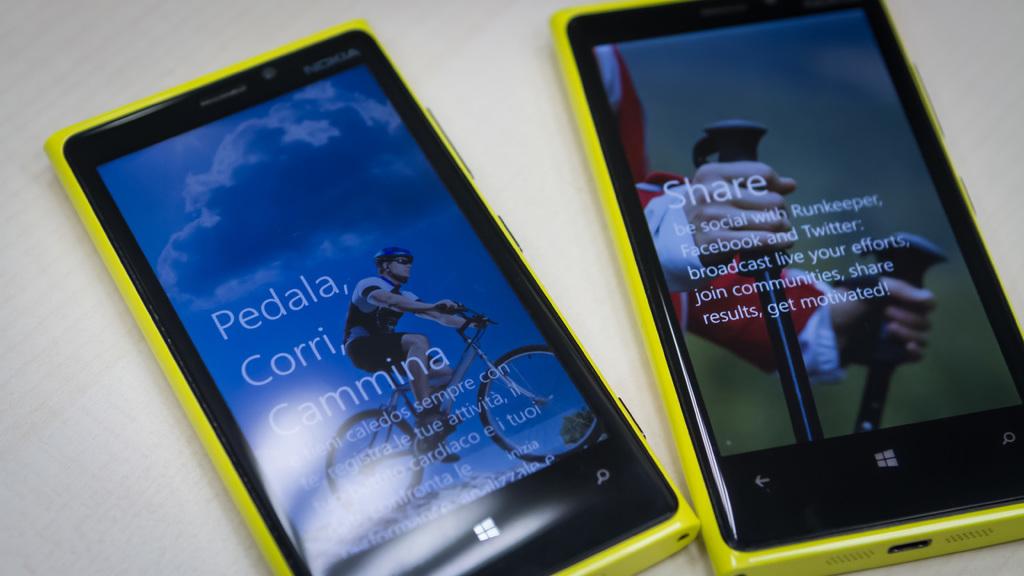What word is in large text on the phone to the right?
Ensure brevity in your answer.  Share. 